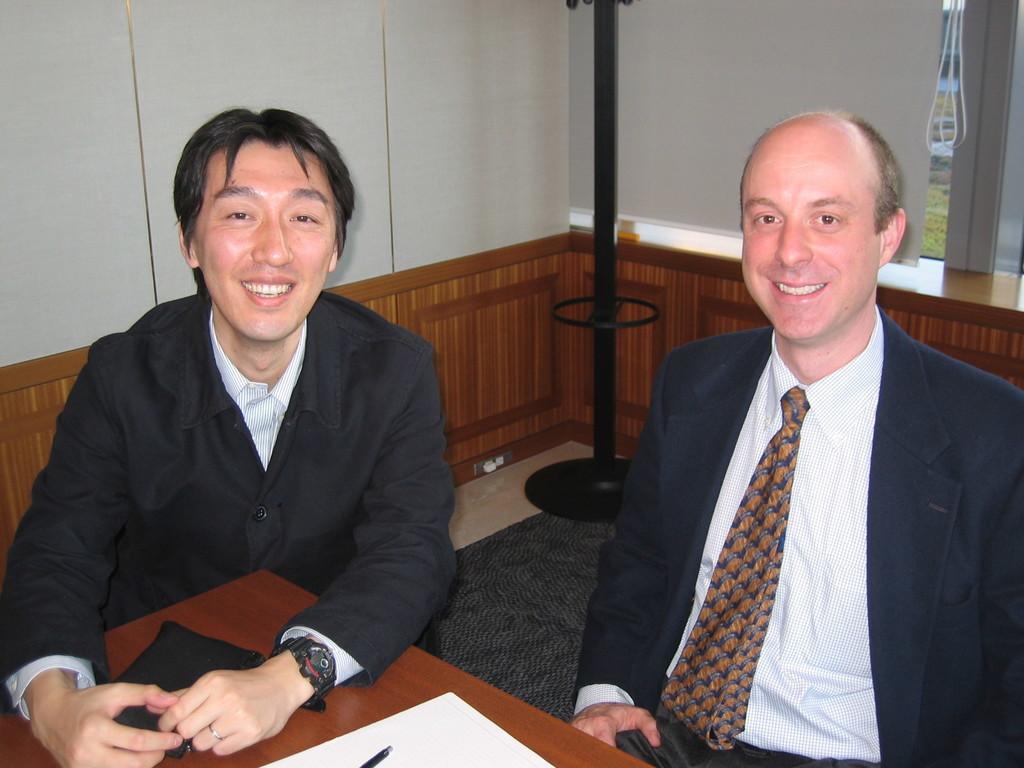Describe this image in one or two sentences. This picture shows the inner view of a room. There are two people sitting near to the wooden table, one paper, one pen and one object on the table. There is one pole stand, one black carpet on the floor, glass window with white curtains, some wires and some grass on the ground. 